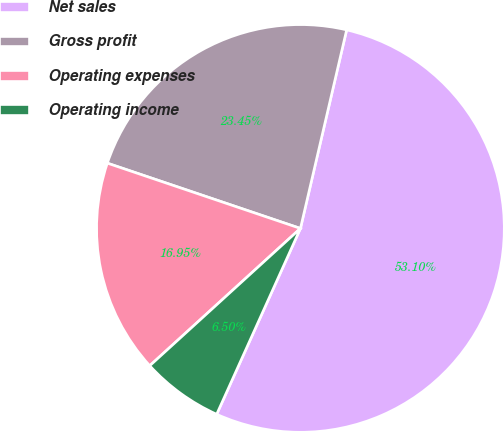Convert chart. <chart><loc_0><loc_0><loc_500><loc_500><pie_chart><fcel>Net sales<fcel>Gross profit<fcel>Operating expenses<fcel>Operating income<nl><fcel>53.1%<fcel>23.45%<fcel>16.95%<fcel>6.5%<nl></chart> 